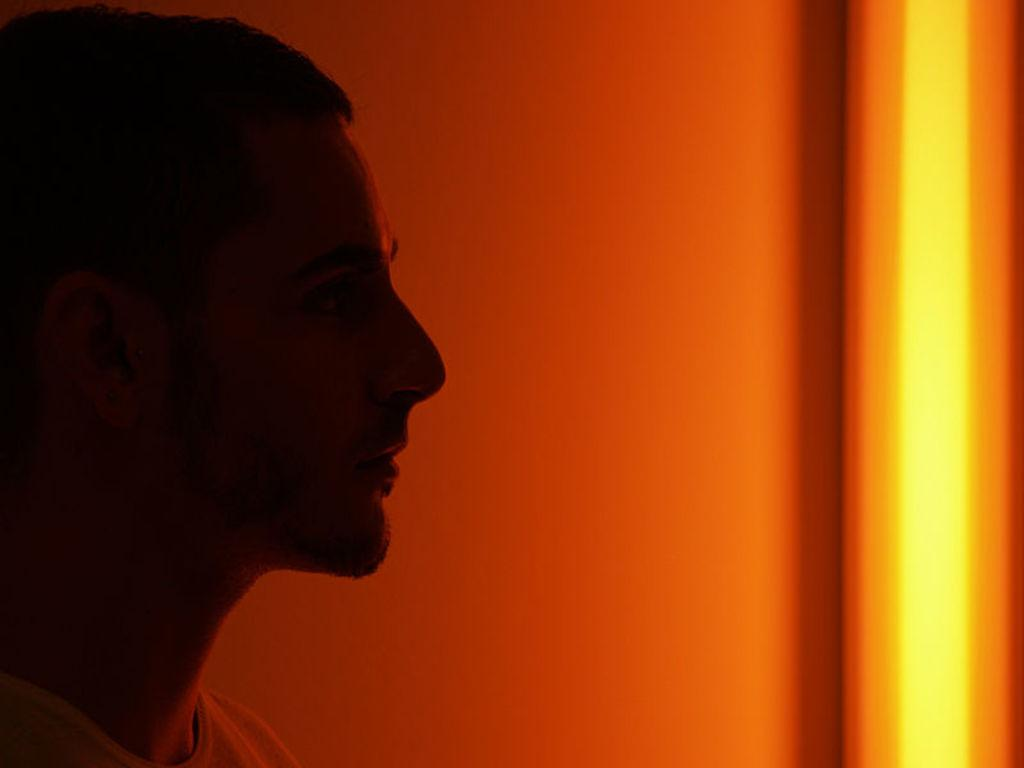Who or what is on the left side of the image? There is a person on the left side of the image. What can be seen on the right side of the image? There is light on the right side of the image. What is the main object in the middle of the image? There is a well in the middle of the image. What type of quartz is being used for reading in the image? There is no quartz or reading activity present in the image. Can you compare the size of the person to the well in the image? The provided facts do not include information about the size of the person or the well, so it is not possible to make a comparison. 